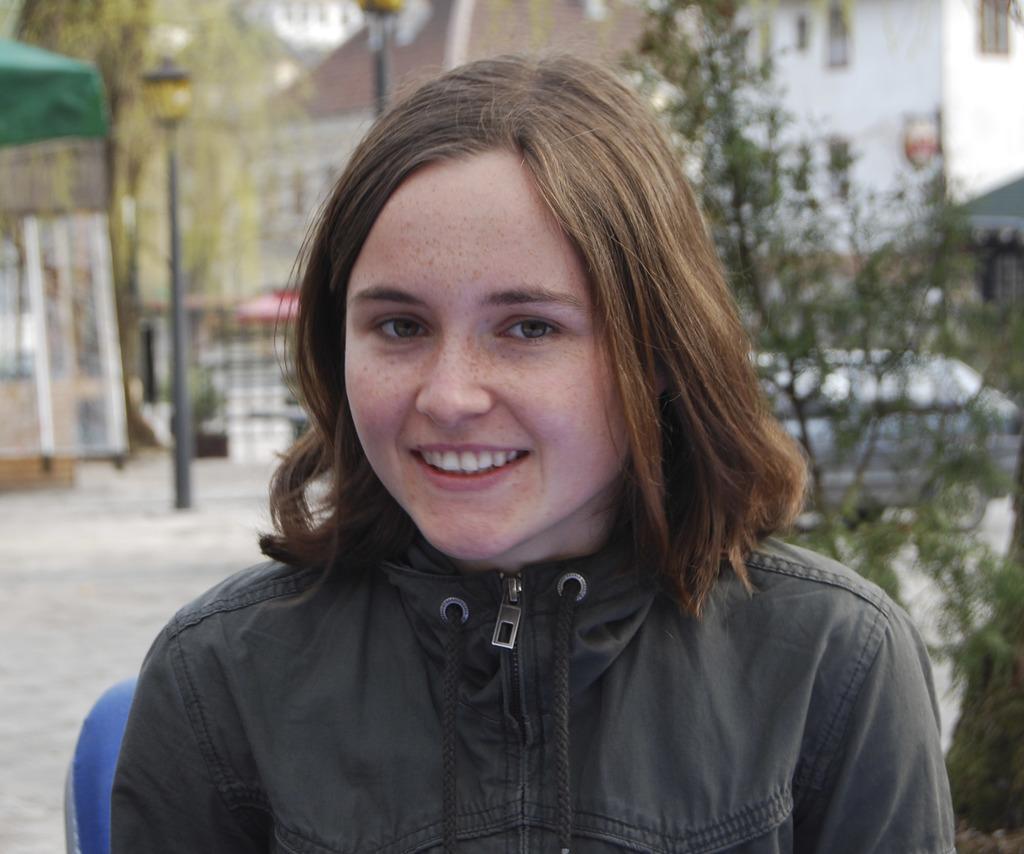Please provide a concise description of this image. Here I can see a woman wearing a black color jacket, smiling and giving pose for the picture. This is an outside view. In the background, I can see some trees, a car, building and few poles on the road. 